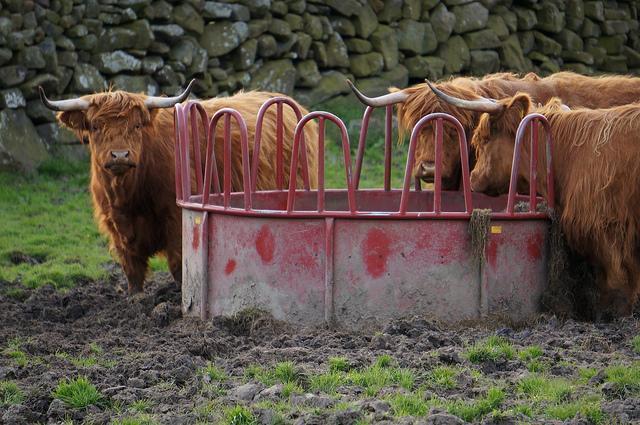How many cows in the picture?
Give a very brief answer. 3. How many cows are there?
Give a very brief answer. 3. How many types of apples do you see?
Give a very brief answer. 0. 